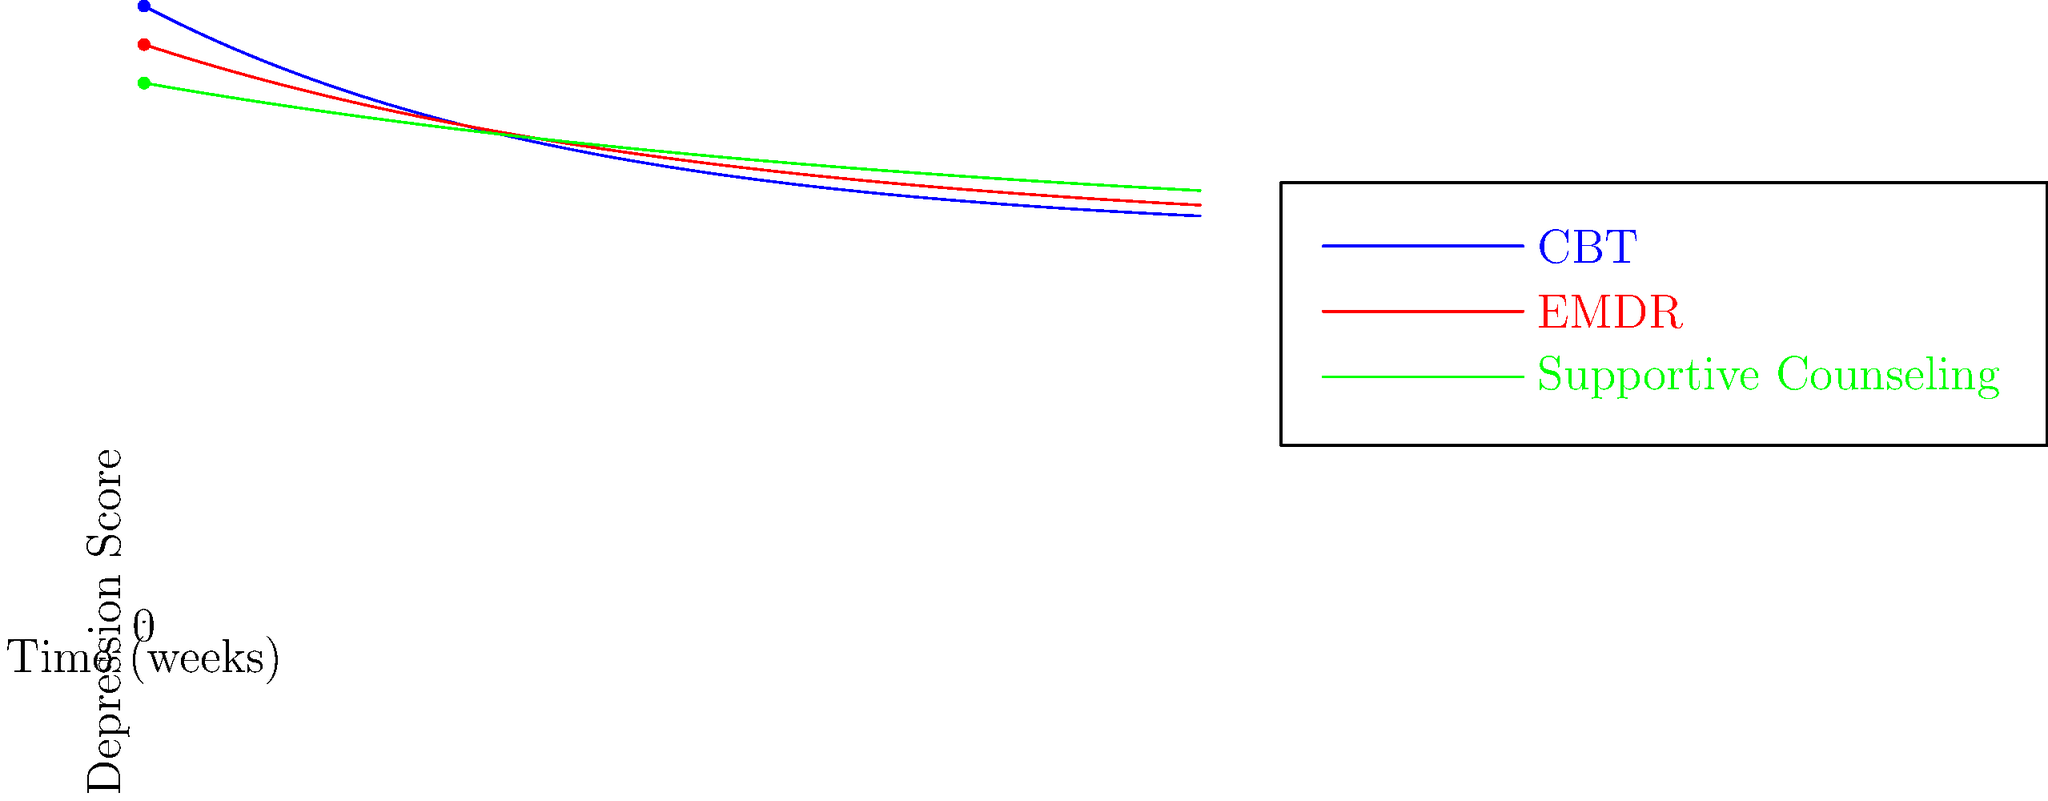Based on the line graph depicting the effectiveness of various therapies for treating depression in veterans over time, which therapy shows the most rapid initial decrease in depression scores during the first 4 weeks of treatment? To determine which therapy shows the most rapid initial decrease in depression scores during the first 4 weeks, we need to analyze the slopes of each line from week 0 to week 4:

1. Cognitive Behavioral Therapy (CBT) - Blue line:
   - Starts at approximately 80
   - At week 4, score is approximately 62
   - Decrease: 80 - 62 = 18 points

2. Eye Movement Desensitization and Reprocessing (EMDR) - Red line:
   - Starts at approximately 75
   - At week 4, score is approximately 63
   - Decrease: 75 - 63 = 12 points

3. Supportive Counseling - Green line:
   - Starts at approximately 70
   - At week 4, score is approximately 63
   - Decrease: 70 - 63 = 7 points

CBT shows the steepest decline and the largest decrease in depression scores (18 points) during the first 4 weeks, indicating the most rapid initial improvement among the three therapies.
Answer: Cognitive Behavioral Therapy (CBT) 